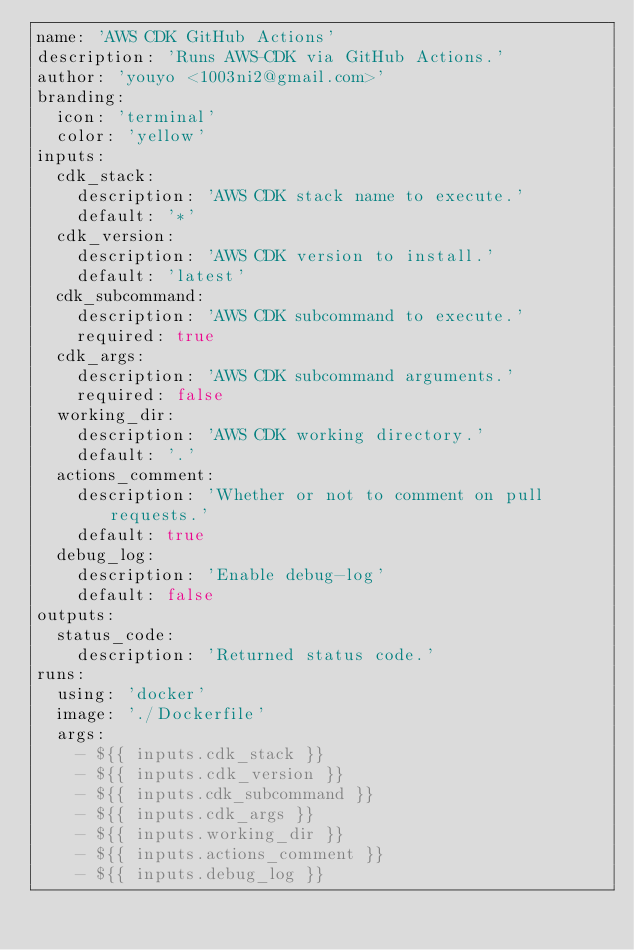<code> <loc_0><loc_0><loc_500><loc_500><_YAML_>name: 'AWS CDK GitHub Actions'
description: 'Runs AWS-CDK via GitHub Actions.'
author: 'youyo <1003ni2@gmail.com>'
branding:
  icon: 'terminal'
  color: 'yellow'
inputs:
  cdk_stack:
    description: 'AWS CDK stack name to execute.'
    default: '*'
  cdk_version:
    description: 'AWS CDK version to install.'
    default: 'latest'
  cdk_subcommand:
    description: 'AWS CDK subcommand to execute.'
    required: true
  cdk_args:
    description: 'AWS CDK subcommand arguments.'
    required: false
  working_dir:
    description: 'AWS CDK working directory.'
    default: '.'
  actions_comment:
    description: 'Whether or not to comment on pull requests.'
    default: true
  debug_log:
    description: 'Enable debug-log'
    default: false
outputs:
  status_code:
    description: 'Returned status code.'
runs:
  using: 'docker'
  image: './Dockerfile'
  args:
    - ${{ inputs.cdk_stack }}
    - ${{ inputs.cdk_version }}
    - ${{ inputs.cdk_subcommand }}
    - ${{ inputs.cdk_args }}
    - ${{ inputs.working_dir }}
    - ${{ inputs.actions_comment }}
    - ${{ inputs.debug_log }}
</code> 